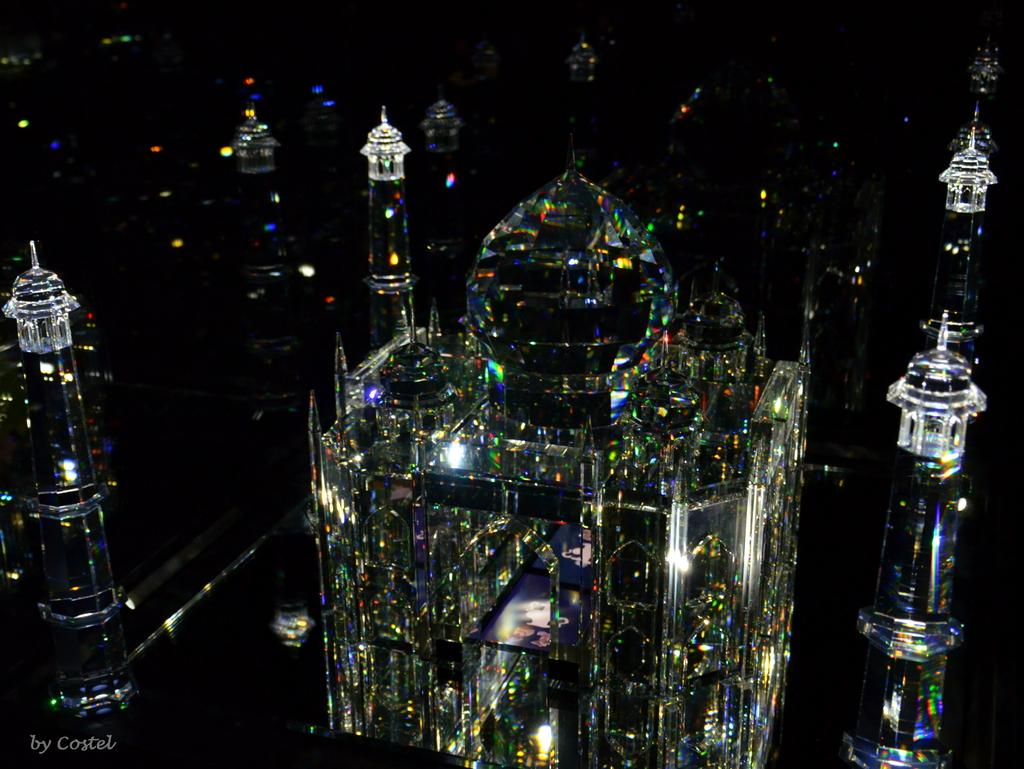What is the overall lighting condition of the image? The image is dark. What type of structures can be seen in the image? There are ancient architectures in the image. Where is the text located in the image? The text is in the bottom left side of the image. What type of cart is visible in the image? There is no cart present in the image. What process is being depicted in the image? The image does not depict a specific process; it primarily features ancient architectures. 